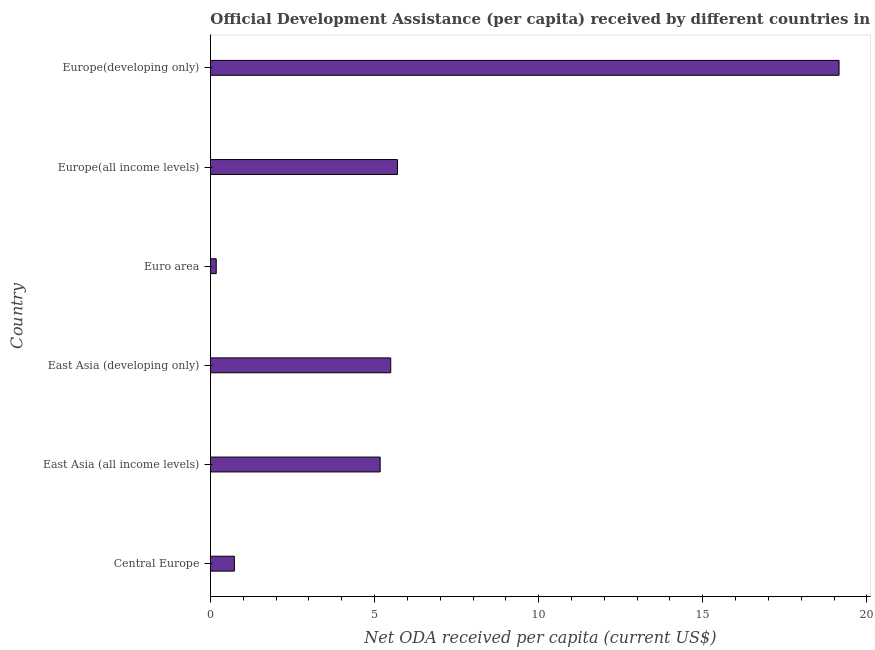What is the title of the graph?
Offer a very short reply. Official Development Assistance (per capita) received by different countries in the year 1999. What is the label or title of the X-axis?
Offer a terse response. Net ODA received per capita (current US$). What is the label or title of the Y-axis?
Provide a succinct answer. Country. What is the net oda received per capita in Europe(developing only)?
Your answer should be compact. 19.15. Across all countries, what is the maximum net oda received per capita?
Offer a terse response. 19.15. Across all countries, what is the minimum net oda received per capita?
Keep it short and to the point. 0.18. In which country was the net oda received per capita maximum?
Your answer should be very brief. Europe(developing only). What is the sum of the net oda received per capita?
Give a very brief answer. 36.42. What is the difference between the net oda received per capita in East Asia (all income levels) and Euro area?
Make the answer very short. 5. What is the average net oda received per capita per country?
Make the answer very short. 6.07. What is the median net oda received per capita?
Your answer should be very brief. 5.33. What is the ratio of the net oda received per capita in Central Europe to that in Europe(all income levels)?
Give a very brief answer. 0.13. What is the difference between the highest and the second highest net oda received per capita?
Keep it short and to the point. 13.45. Is the sum of the net oda received per capita in East Asia (developing only) and Euro area greater than the maximum net oda received per capita across all countries?
Ensure brevity in your answer.  No. What is the difference between the highest and the lowest net oda received per capita?
Your answer should be compact. 18.98. In how many countries, is the net oda received per capita greater than the average net oda received per capita taken over all countries?
Your response must be concise. 1. How many bars are there?
Your answer should be compact. 6. Are all the bars in the graph horizontal?
Offer a very short reply. Yes. What is the difference between two consecutive major ticks on the X-axis?
Provide a succinct answer. 5. Are the values on the major ticks of X-axis written in scientific E-notation?
Your answer should be very brief. No. What is the Net ODA received per capita (current US$) in Central Europe?
Keep it short and to the point. 0.73. What is the Net ODA received per capita (current US$) of East Asia (all income levels)?
Ensure brevity in your answer.  5.17. What is the Net ODA received per capita (current US$) in East Asia (developing only)?
Provide a succinct answer. 5.49. What is the Net ODA received per capita (current US$) of Euro area?
Your answer should be very brief. 0.18. What is the Net ODA received per capita (current US$) of Europe(all income levels)?
Your response must be concise. 5.7. What is the Net ODA received per capita (current US$) in Europe(developing only)?
Provide a succinct answer. 19.15. What is the difference between the Net ODA received per capita (current US$) in Central Europe and East Asia (all income levels)?
Your answer should be very brief. -4.44. What is the difference between the Net ODA received per capita (current US$) in Central Europe and East Asia (developing only)?
Keep it short and to the point. -4.76. What is the difference between the Net ODA received per capita (current US$) in Central Europe and Euro area?
Provide a succinct answer. 0.55. What is the difference between the Net ODA received per capita (current US$) in Central Europe and Europe(all income levels)?
Offer a very short reply. -4.97. What is the difference between the Net ODA received per capita (current US$) in Central Europe and Europe(developing only)?
Your answer should be compact. -18.42. What is the difference between the Net ODA received per capita (current US$) in East Asia (all income levels) and East Asia (developing only)?
Your answer should be compact. -0.32. What is the difference between the Net ODA received per capita (current US$) in East Asia (all income levels) and Euro area?
Make the answer very short. 4.99. What is the difference between the Net ODA received per capita (current US$) in East Asia (all income levels) and Europe(all income levels)?
Provide a succinct answer. -0.53. What is the difference between the Net ODA received per capita (current US$) in East Asia (all income levels) and Europe(developing only)?
Keep it short and to the point. -13.98. What is the difference between the Net ODA received per capita (current US$) in East Asia (developing only) and Euro area?
Your answer should be very brief. 5.32. What is the difference between the Net ODA received per capita (current US$) in East Asia (developing only) and Europe(all income levels)?
Keep it short and to the point. -0.21. What is the difference between the Net ODA received per capita (current US$) in East Asia (developing only) and Europe(developing only)?
Your response must be concise. -13.66. What is the difference between the Net ODA received per capita (current US$) in Euro area and Europe(all income levels)?
Make the answer very short. -5.52. What is the difference between the Net ODA received per capita (current US$) in Euro area and Europe(developing only)?
Offer a very short reply. -18.98. What is the difference between the Net ODA received per capita (current US$) in Europe(all income levels) and Europe(developing only)?
Offer a terse response. -13.45. What is the ratio of the Net ODA received per capita (current US$) in Central Europe to that in East Asia (all income levels)?
Your answer should be compact. 0.14. What is the ratio of the Net ODA received per capita (current US$) in Central Europe to that in East Asia (developing only)?
Offer a very short reply. 0.13. What is the ratio of the Net ODA received per capita (current US$) in Central Europe to that in Euro area?
Ensure brevity in your answer.  4.15. What is the ratio of the Net ODA received per capita (current US$) in Central Europe to that in Europe(all income levels)?
Make the answer very short. 0.13. What is the ratio of the Net ODA received per capita (current US$) in Central Europe to that in Europe(developing only)?
Provide a short and direct response. 0.04. What is the ratio of the Net ODA received per capita (current US$) in East Asia (all income levels) to that in East Asia (developing only)?
Offer a terse response. 0.94. What is the ratio of the Net ODA received per capita (current US$) in East Asia (all income levels) to that in Euro area?
Keep it short and to the point. 29.46. What is the ratio of the Net ODA received per capita (current US$) in East Asia (all income levels) to that in Europe(all income levels)?
Keep it short and to the point. 0.91. What is the ratio of the Net ODA received per capita (current US$) in East Asia (all income levels) to that in Europe(developing only)?
Give a very brief answer. 0.27. What is the ratio of the Net ODA received per capita (current US$) in East Asia (developing only) to that in Euro area?
Ensure brevity in your answer.  31.29. What is the ratio of the Net ODA received per capita (current US$) in East Asia (developing only) to that in Europe(all income levels)?
Make the answer very short. 0.96. What is the ratio of the Net ODA received per capita (current US$) in East Asia (developing only) to that in Europe(developing only)?
Your response must be concise. 0.29. What is the ratio of the Net ODA received per capita (current US$) in Euro area to that in Europe(all income levels)?
Your answer should be very brief. 0.03. What is the ratio of the Net ODA received per capita (current US$) in Euro area to that in Europe(developing only)?
Provide a succinct answer. 0.01. What is the ratio of the Net ODA received per capita (current US$) in Europe(all income levels) to that in Europe(developing only)?
Keep it short and to the point. 0.3. 